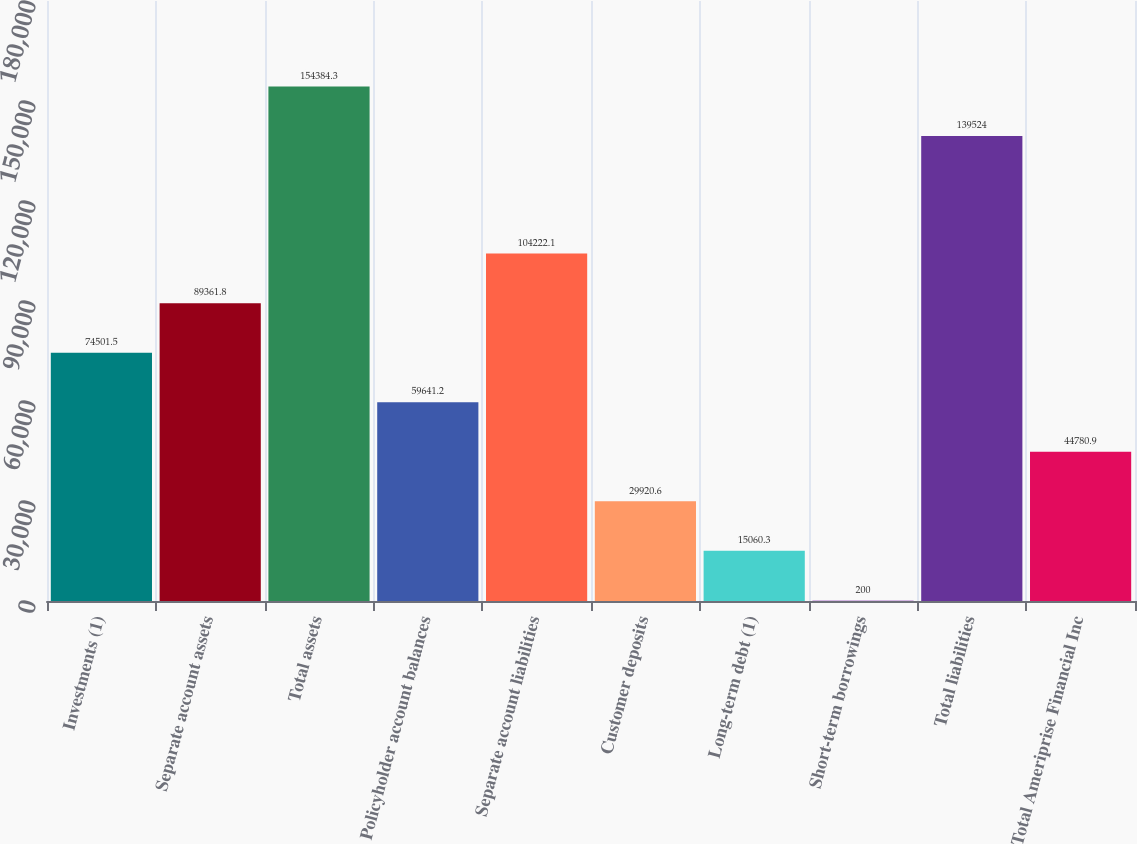Convert chart to OTSL. <chart><loc_0><loc_0><loc_500><loc_500><bar_chart><fcel>Investments (1)<fcel>Separate account assets<fcel>Total assets<fcel>Policyholder account balances<fcel>Separate account liabilities<fcel>Customer deposits<fcel>Long-term debt (1)<fcel>Short-term borrowings<fcel>Total liabilities<fcel>Total Ameriprise Financial Inc<nl><fcel>74501.5<fcel>89361.8<fcel>154384<fcel>59641.2<fcel>104222<fcel>29920.6<fcel>15060.3<fcel>200<fcel>139524<fcel>44780.9<nl></chart> 